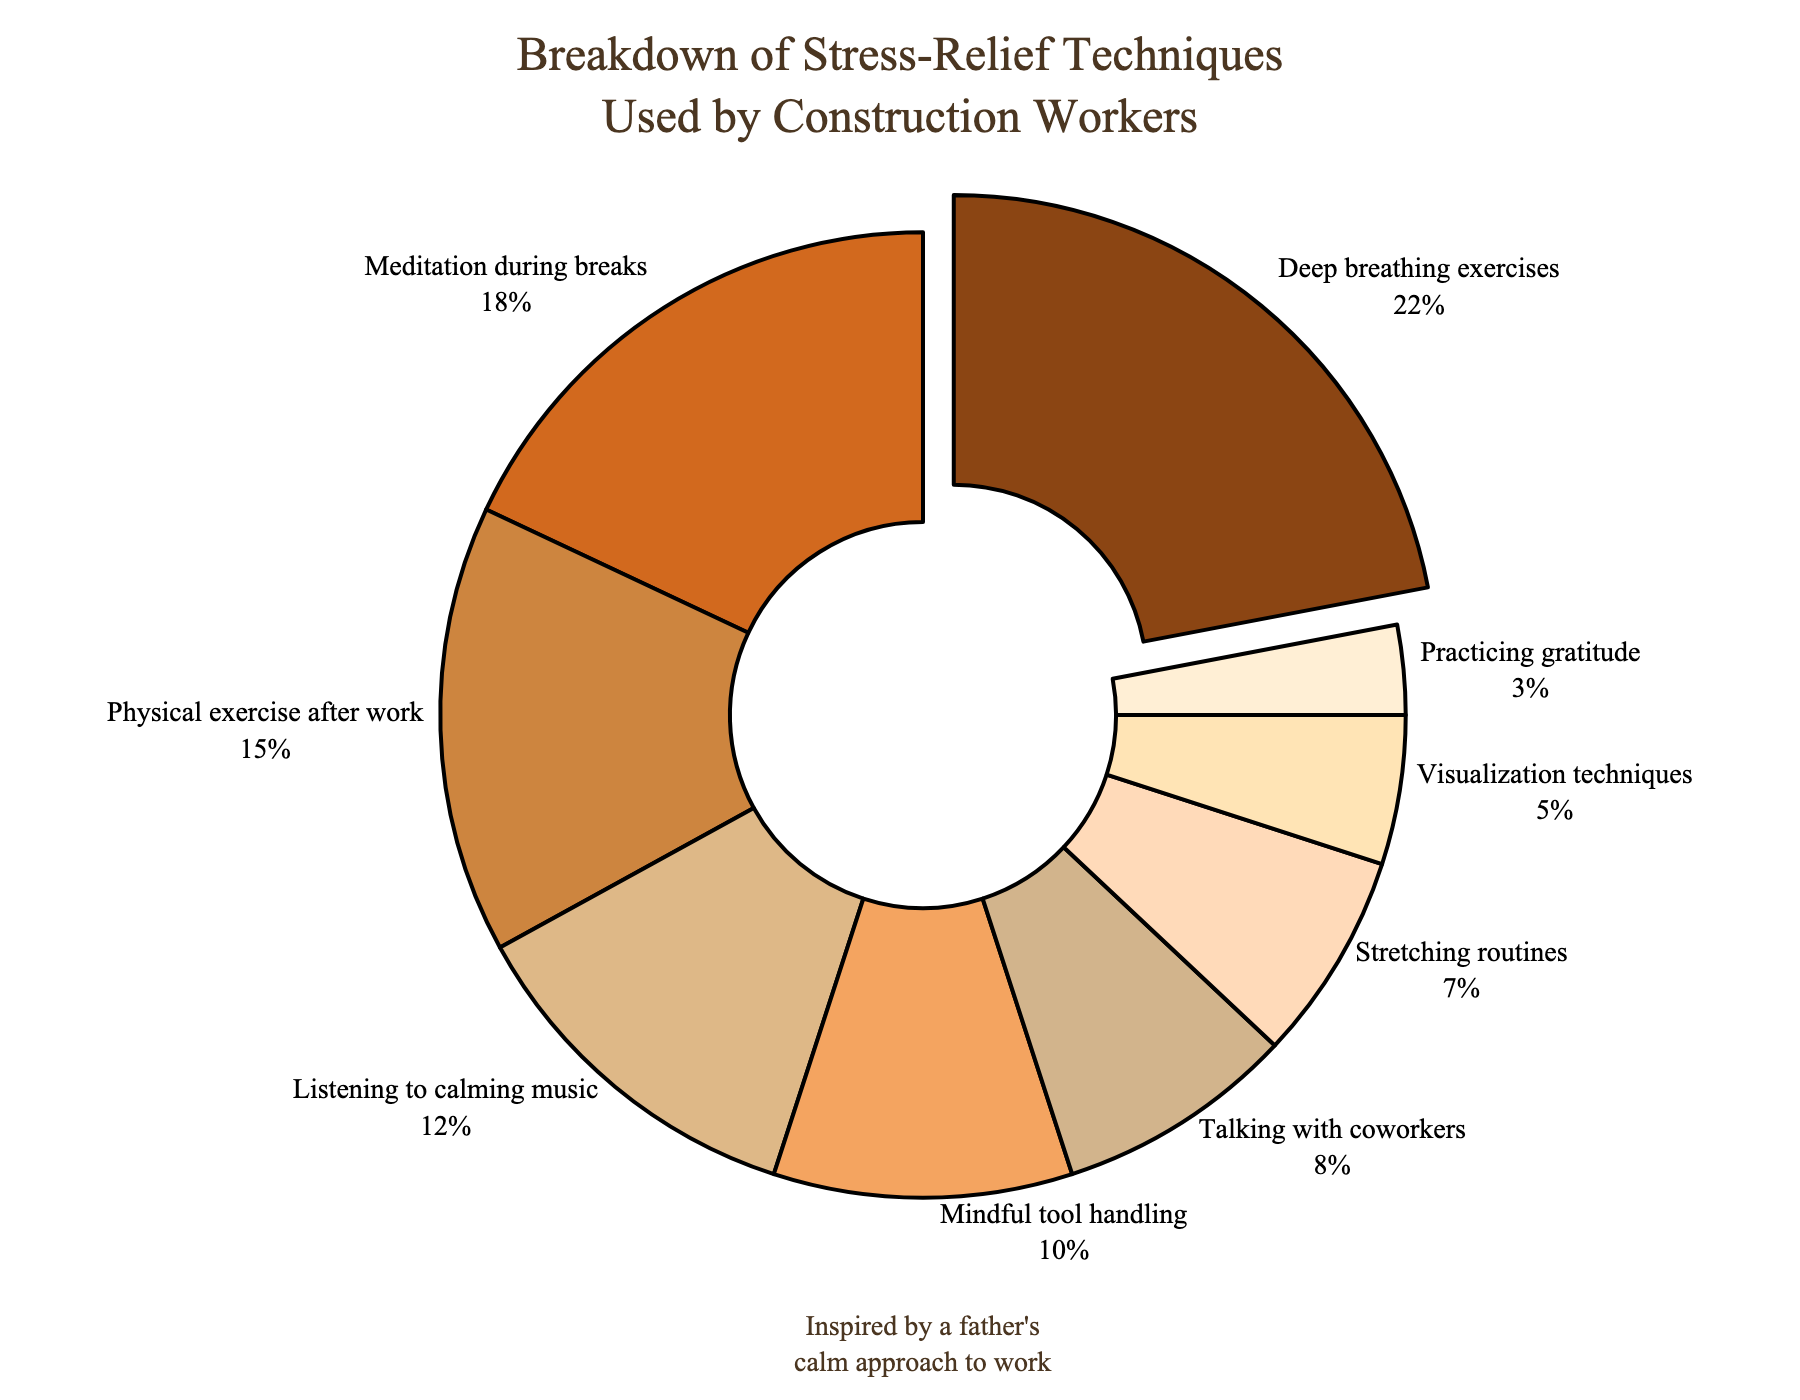What's the most commonly used stress-relief technique among construction workers? The pie chart shows various stress-relief techniques with their respective percentages. The largest segment is for "Deep breathing exercises" with 22%.
Answer: Deep breathing exercises How much more popular is "Deep breathing exercises" compared to "Practicing gratitude"? To find the difference in popularity, subtract the percentage of "Practicing gratitude" from "Deep breathing exercises". 22% - 3% = 19%.
Answer: 19% What percentage of workers use either "Physical exercise after work" or "Listening to calming music"? Sum the percentages for "Physical exercise after work" and "Listening to calming music". 15% + 12% = 27%.
Answer: 27% Which technique has a slightly higher percentage: "Talking with coworkers" or "Stretching routines"? Compare the percentages for "Talking with coworkers" (8%) and "Stretching routines" (7%).
Answer: Talking with coworkers What's the combined percentage of techniques that involve physical activities? Physical activities include "Physical exercise after work" and "Stretching routines". Adding their percentages, 15% + 7% = 22%.
Answer: 22% How many techniques have a percentage of 10% or higher? Identify and count the segments with percentages 10% or higher. Deep breathing exercises (22%), Meditation during breaks (18%), Physical exercise after work (15%), Listening to calming music (12%), and Mindful tool handling (10%) make up 5 techniques.
Answer: 5 Which technique is represented with a slightly darker shade of brown than "D2691E"? The pie chart uses varying shades of brown. The technique just slightly darker than "D2691E" (Meditation during breaks) is "Deep breathing exercises" with color "#8B4513".
Answer: Deep breathing exercises What is the least used stress-relief technique among construction workers? The smallest segment in the pie chart is labeled "Practicing gratitude" with 3%.
Answer: Practicing gratitude 